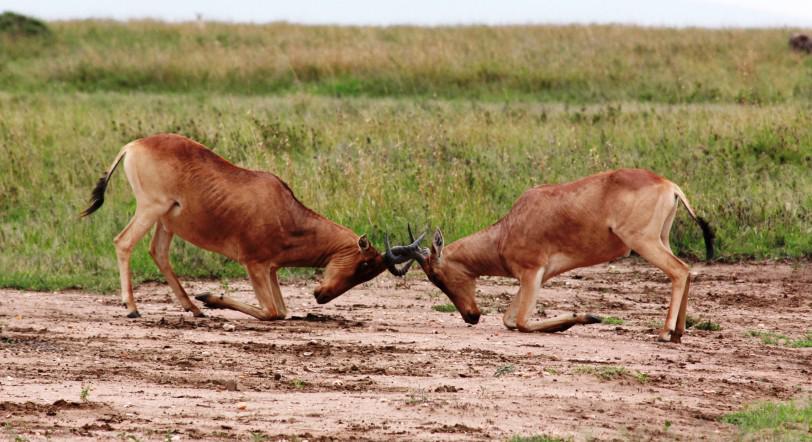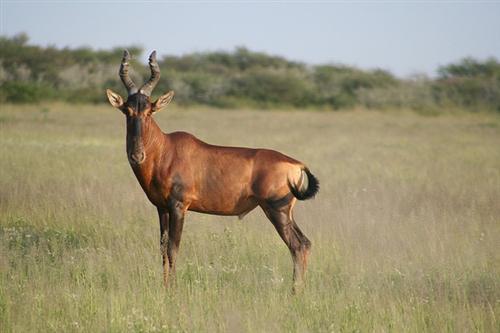The first image is the image on the left, the second image is the image on the right. Analyze the images presented: Is the assertion "An image shows exactly two antelope that are not sparring." valid? Answer yes or no. No. 